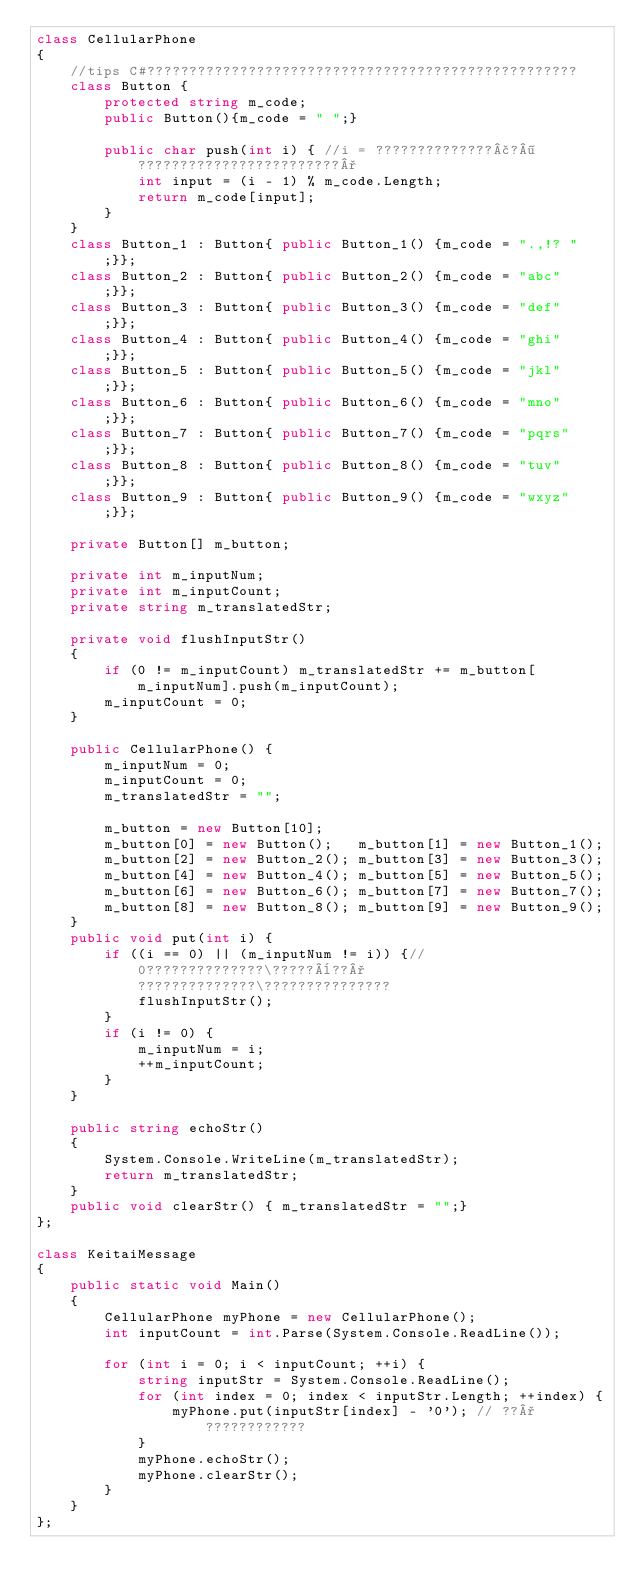Convert code to text. <code><loc_0><loc_0><loc_500><loc_500><_C#_>class CellularPhone
{
	//tips C#???????????????????????????????????????????????????
	class Button {
		protected string m_code;
		public Button(){m_code = " ";}
		
		public char push(int i) { //i = ??????????????£?¶????????????????????????°
			int input = (i - 1) % m_code.Length;
			return m_code[input];
		}
	}
	class Button_1 : Button{ public Button_1() {m_code = ".,!? ";}};
	class Button_2 : Button{ public Button_2() {m_code = "abc"  ;}};
	class Button_3 : Button{ public Button_3() {m_code = "def"  ;}};
	class Button_4 : Button{ public Button_4() {m_code = "ghi"  ;}};
	class Button_5 : Button{ public Button_5() {m_code = "jkl"  ;}};
	class Button_6 : Button{ public Button_6() {m_code = "mno"  ;}};
	class Button_7 : Button{ public Button_7() {m_code = "pqrs" ;}};
	class Button_8 : Button{ public Button_8() {m_code = "tuv"  ;}};
	class Button_9 : Button{ public Button_9() {m_code = "wxyz" ;}};
	
	private Button[] m_button;
	
	private int m_inputNum;
	private int m_inputCount;
	private string m_translatedStr;
	
	private void flushInputStr()
	{
		if (0 != m_inputCount) m_translatedStr += m_button[m_inputNum].push(m_inputCount);
		m_inputCount = 0;
	}
	
	public CellularPhone() {
		m_inputNum = 0;
		m_inputCount = 0;
		m_translatedStr = "";

		m_button = new Button[10];
		m_button[0] = new Button();   m_button[1] = new Button_1(); 
		m_button[2] = new Button_2(); m_button[3] = new Button_3();
		m_button[4] = new Button_4(); m_button[5] = new Button_5();
		m_button[6] = new Button_6(); m_button[7] = new Button_7();
		m_button[8] = new Button_8(); m_button[9] = new Button_9();
	}
	public void put(int i) {
		if ((i == 0) || (m_inputNum != i)) {// 0??????????????\?????¨??°??????????????\???????????????
			flushInputStr();
		}
		if (i != 0) {
			m_inputNum = i;
			++m_inputCount;
		}
	}
	
	public string echoStr() 
	{
		System.Console.WriteLine(m_translatedStr);
		return m_translatedStr;
	}
	public void clearStr() { m_translatedStr = "";}
};

class KeitaiMessage
{
	public static void Main()
	{
		CellularPhone myPhone = new CellularPhone();
		int inputCount = int.Parse(System.Console.ReadLine());
		
		for (int i = 0; i < inputCount; ++i) {
			string inputStr = System.Console.ReadLine();
			for (int index = 0; index < inputStr.Length; ++index) {
				myPhone.put(inputStr[index] - '0'); // ??°????????????
			}
			myPhone.echoStr();
			myPhone.clearStr();
		}
	}
};

	
	</code> 